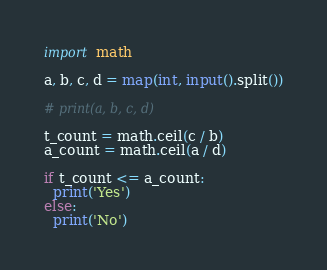Convert code to text. <code><loc_0><loc_0><loc_500><loc_500><_Python_>import math

a, b, c, d = map(int, input().split())

# print(a, b, c, d)

t_count = math.ceil(c / b)
a_count = math.ceil(a / d)

if t_count <= a_count:
  print('Yes')
else:
  print('No')</code> 